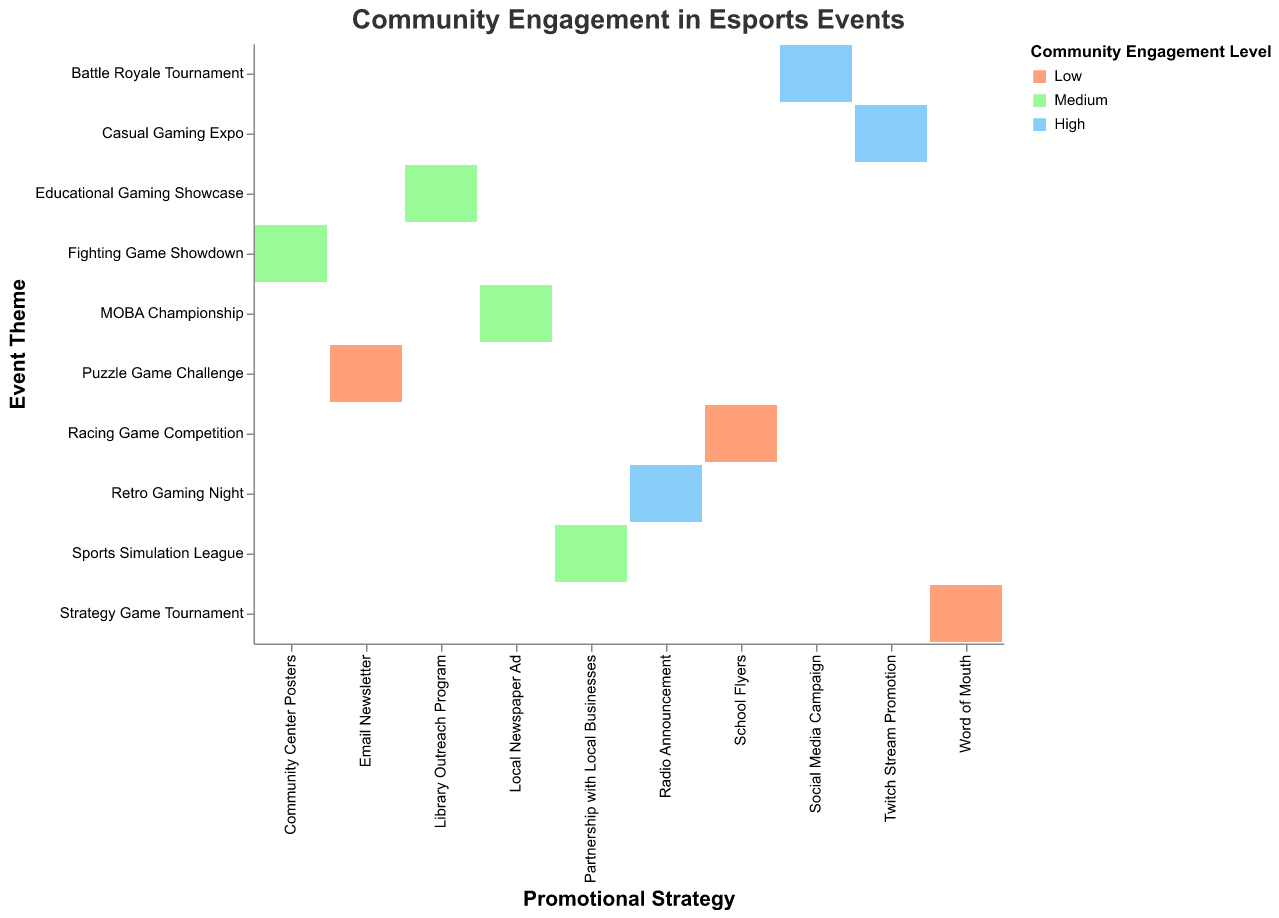What is the title of the plot? The title is usually found at the top of the plot and provides the main subject or focus of the visualization. Here, it reads "Community Engagement in Esports Events".
Answer: Community Engagement in Esports Events Which promotional strategy is associated with the highest community engagement in a Casual Gaming Expo? To find this, look at the column for "Casual Gaming Expo" in the Event Theme axis and see which promotional strategy has the color corresponding to "High" engagement.
Answer: Twitch Stream Promotion How many event themes result in medium community engagement? To determine this, count the boxes colored for "Medium" community engagement across all event themes. These colors are usually intermediate shades in the color scale provided.
Answer: 4 For a "Puzzle Game Challenge" event, what is the community engagement level when promoted through Email Newsletter? Look at the "Puzzle Game Challenge" row under the Event Theme axis and find the corresponding promotional strategy on the x-axis. Check its community engagement color.
Answer: Low Which promotional strategy leads to the lowest engagement for a Strategy Game Tournament? To answer this, check the column for "Strategy Game Tournament" and identify the color representing "Low" engagement, then see which promotional strategy is listed.
Answer: Word of Mouth Which promotional strategies lead to high community engagement overall? Look at all boxes colored for "High" across different event themes and note the respective promotional strategies listed on the x-axis.
Answer: Social Media Campaign, Radio Announcement, Twitch Stream Promotion Is there any event theme associated with all three levels of community engagement? For this, scan through each event theme (row) to see if it contains boxes of all three engagement colors: Low, Medium, and High.
Answer: No How does community engagement among different promotional strategies compare for "MOBA Championship"? Compare the engagement levels indicated by different colors in the "MOBA Championship" row, and note the variations.
Answer: Medium engagement via Local Newspaper Ad Out of all event themes, which one shows the highest frequency of high community engagement? Count the number of high community engagement colors across all event themes and see which theme has the most.
Answer: No single theme has the highest frequency; each "High" engagement level appears for different themes What is the community engagement level for the "Educational Gaming Showcase" when promoted with a Library Outreach Program? Find the row for "Educational Gaming Showcase" under Event Theme and see the engagement level color for the "Library Outreach Program" promotional strategy.
Answer: Medium 